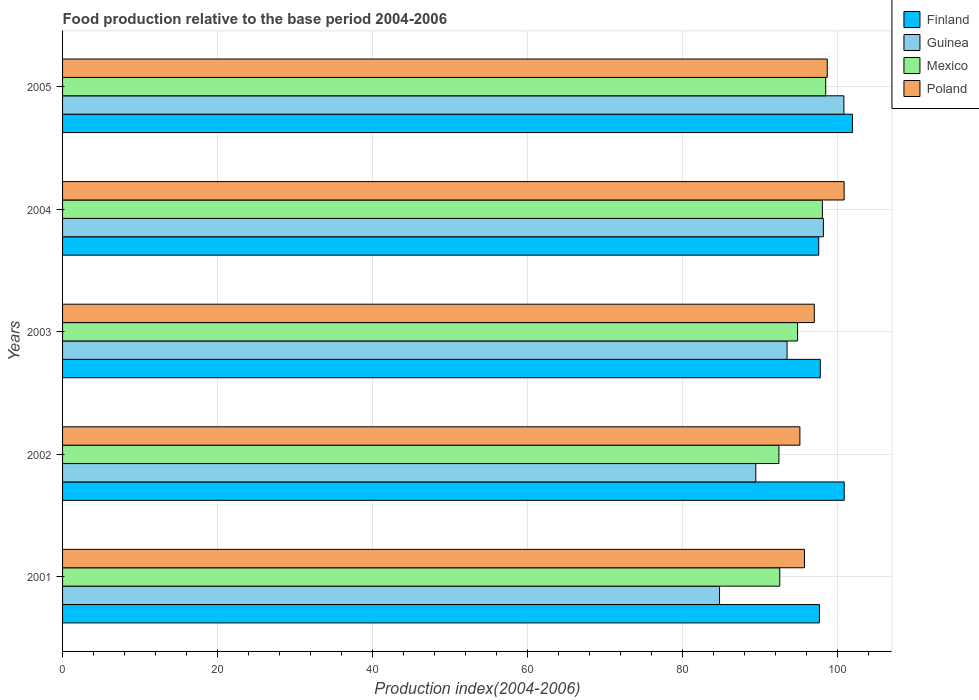Are the number of bars per tick equal to the number of legend labels?
Provide a succinct answer. Yes. Are the number of bars on each tick of the Y-axis equal?
Offer a very short reply. Yes. How many bars are there on the 3rd tick from the top?
Offer a terse response. 4. What is the label of the 3rd group of bars from the top?
Your response must be concise. 2003. What is the food production index in Poland in 2004?
Give a very brief answer. 100.87. Across all years, what is the maximum food production index in Poland?
Make the answer very short. 100.87. Across all years, what is the minimum food production index in Mexico?
Your answer should be very brief. 92.45. In which year was the food production index in Poland maximum?
Provide a short and direct response. 2004. In which year was the food production index in Poland minimum?
Provide a succinct answer. 2002. What is the total food production index in Poland in the graph?
Make the answer very short. 487.49. What is the difference between the food production index in Mexico in 2001 and that in 2002?
Offer a terse response. 0.11. What is the difference between the food production index in Poland in 2004 and the food production index in Mexico in 2003?
Offer a very short reply. 6.01. What is the average food production index in Mexico per year?
Provide a short and direct response. 95.28. In the year 2005, what is the difference between the food production index in Mexico and food production index in Finland?
Give a very brief answer. -3.45. In how many years, is the food production index in Guinea greater than 40 ?
Your answer should be very brief. 5. What is the ratio of the food production index in Finland in 2002 to that in 2004?
Your response must be concise. 1.03. Is the food production index in Finland in 2002 less than that in 2004?
Your answer should be very brief. No. What is the difference between the highest and the second highest food production index in Poland?
Offer a very short reply. 2.18. What is the difference between the highest and the lowest food production index in Poland?
Your response must be concise. 5.71. In how many years, is the food production index in Poland greater than the average food production index in Poland taken over all years?
Give a very brief answer. 2. Is it the case that in every year, the sum of the food production index in Mexico and food production index in Poland is greater than the sum of food production index in Guinea and food production index in Finland?
Your answer should be compact. No. What does the 3rd bar from the top in 2003 represents?
Offer a very short reply. Guinea. What does the 2nd bar from the bottom in 2005 represents?
Your response must be concise. Guinea. How many bars are there?
Ensure brevity in your answer.  20. What is the difference between two consecutive major ticks on the X-axis?
Keep it short and to the point. 20. Are the values on the major ticks of X-axis written in scientific E-notation?
Your answer should be compact. No. Does the graph contain any zero values?
Your answer should be compact. No. Where does the legend appear in the graph?
Give a very brief answer. Top right. How many legend labels are there?
Provide a succinct answer. 4. How are the legend labels stacked?
Your response must be concise. Vertical. What is the title of the graph?
Your response must be concise. Food production relative to the base period 2004-2006. What is the label or title of the X-axis?
Provide a succinct answer. Production index(2004-2006). What is the Production index(2004-2006) of Finland in 2001?
Ensure brevity in your answer.  97.68. What is the Production index(2004-2006) in Guinea in 2001?
Provide a succinct answer. 84.79. What is the Production index(2004-2006) in Mexico in 2001?
Your answer should be very brief. 92.56. What is the Production index(2004-2006) of Poland in 2001?
Give a very brief answer. 95.75. What is the Production index(2004-2006) in Finland in 2002?
Your answer should be very brief. 100.88. What is the Production index(2004-2006) of Guinea in 2002?
Your answer should be compact. 89.47. What is the Production index(2004-2006) in Mexico in 2002?
Provide a succinct answer. 92.45. What is the Production index(2004-2006) in Poland in 2002?
Give a very brief answer. 95.16. What is the Production index(2004-2006) of Finland in 2003?
Your answer should be compact. 97.79. What is the Production index(2004-2006) of Guinea in 2003?
Provide a succinct answer. 93.5. What is the Production index(2004-2006) in Mexico in 2003?
Your answer should be very brief. 94.86. What is the Production index(2004-2006) of Poland in 2003?
Your answer should be compact. 97.02. What is the Production index(2004-2006) in Finland in 2004?
Your response must be concise. 97.59. What is the Production index(2004-2006) in Guinea in 2004?
Make the answer very short. 98.19. What is the Production index(2004-2006) of Mexico in 2004?
Your response must be concise. 98.06. What is the Production index(2004-2006) in Poland in 2004?
Provide a short and direct response. 100.87. What is the Production index(2004-2006) in Finland in 2005?
Provide a short and direct response. 101.94. What is the Production index(2004-2006) of Guinea in 2005?
Give a very brief answer. 100.84. What is the Production index(2004-2006) of Mexico in 2005?
Ensure brevity in your answer.  98.49. What is the Production index(2004-2006) in Poland in 2005?
Ensure brevity in your answer.  98.69. Across all years, what is the maximum Production index(2004-2006) of Finland?
Keep it short and to the point. 101.94. Across all years, what is the maximum Production index(2004-2006) in Guinea?
Your answer should be compact. 100.84. Across all years, what is the maximum Production index(2004-2006) of Mexico?
Keep it short and to the point. 98.49. Across all years, what is the maximum Production index(2004-2006) of Poland?
Offer a very short reply. 100.87. Across all years, what is the minimum Production index(2004-2006) of Finland?
Provide a short and direct response. 97.59. Across all years, what is the minimum Production index(2004-2006) of Guinea?
Offer a terse response. 84.79. Across all years, what is the minimum Production index(2004-2006) in Mexico?
Ensure brevity in your answer.  92.45. Across all years, what is the minimum Production index(2004-2006) in Poland?
Offer a terse response. 95.16. What is the total Production index(2004-2006) of Finland in the graph?
Your response must be concise. 495.88. What is the total Production index(2004-2006) in Guinea in the graph?
Provide a short and direct response. 466.79. What is the total Production index(2004-2006) of Mexico in the graph?
Keep it short and to the point. 476.42. What is the total Production index(2004-2006) in Poland in the graph?
Provide a short and direct response. 487.49. What is the difference between the Production index(2004-2006) of Guinea in 2001 and that in 2002?
Provide a succinct answer. -4.68. What is the difference between the Production index(2004-2006) of Mexico in 2001 and that in 2002?
Give a very brief answer. 0.11. What is the difference between the Production index(2004-2006) of Poland in 2001 and that in 2002?
Make the answer very short. 0.59. What is the difference between the Production index(2004-2006) in Finland in 2001 and that in 2003?
Offer a terse response. -0.11. What is the difference between the Production index(2004-2006) of Guinea in 2001 and that in 2003?
Your response must be concise. -8.71. What is the difference between the Production index(2004-2006) in Poland in 2001 and that in 2003?
Offer a very short reply. -1.27. What is the difference between the Production index(2004-2006) in Finland in 2001 and that in 2004?
Ensure brevity in your answer.  0.09. What is the difference between the Production index(2004-2006) of Guinea in 2001 and that in 2004?
Your answer should be compact. -13.4. What is the difference between the Production index(2004-2006) of Poland in 2001 and that in 2004?
Give a very brief answer. -5.12. What is the difference between the Production index(2004-2006) of Finland in 2001 and that in 2005?
Keep it short and to the point. -4.26. What is the difference between the Production index(2004-2006) in Guinea in 2001 and that in 2005?
Give a very brief answer. -16.05. What is the difference between the Production index(2004-2006) of Mexico in 2001 and that in 2005?
Make the answer very short. -5.93. What is the difference between the Production index(2004-2006) in Poland in 2001 and that in 2005?
Offer a very short reply. -2.94. What is the difference between the Production index(2004-2006) of Finland in 2002 and that in 2003?
Your answer should be very brief. 3.09. What is the difference between the Production index(2004-2006) in Guinea in 2002 and that in 2003?
Ensure brevity in your answer.  -4.03. What is the difference between the Production index(2004-2006) of Mexico in 2002 and that in 2003?
Offer a very short reply. -2.41. What is the difference between the Production index(2004-2006) in Poland in 2002 and that in 2003?
Your answer should be very brief. -1.86. What is the difference between the Production index(2004-2006) of Finland in 2002 and that in 2004?
Ensure brevity in your answer.  3.29. What is the difference between the Production index(2004-2006) in Guinea in 2002 and that in 2004?
Make the answer very short. -8.72. What is the difference between the Production index(2004-2006) in Mexico in 2002 and that in 2004?
Ensure brevity in your answer.  -5.61. What is the difference between the Production index(2004-2006) of Poland in 2002 and that in 2004?
Your answer should be compact. -5.71. What is the difference between the Production index(2004-2006) in Finland in 2002 and that in 2005?
Give a very brief answer. -1.06. What is the difference between the Production index(2004-2006) in Guinea in 2002 and that in 2005?
Your answer should be very brief. -11.37. What is the difference between the Production index(2004-2006) of Mexico in 2002 and that in 2005?
Provide a succinct answer. -6.04. What is the difference between the Production index(2004-2006) in Poland in 2002 and that in 2005?
Make the answer very short. -3.53. What is the difference between the Production index(2004-2006) in Guinea in 2003 and that in 2004?
Make the answer very short. -4.69. What is the difference between the Production index(2004-2006) of Poland in 2003 and that in 2004?
Keep it short and to the point. -3.85. What is the difference between the Production index(2004-2006) in Finland in 2003 and that in 2005?
Your answer should be very brief. -4.15. What is the difference between the Production index(2004-2006) in Guinea in 2003 and that in 2005?
Ensure brevity in your answer.  -7.34. What is the difference between the Production index(2004-2006) in Mexico in 2003 and that in 2005?
Offer a terse response. -3.63. What is the difference between the Production index(2004-2006) of Poland in 2003 and that in 2005?
Your answer should be compact. -1.67. What is the difference between the Production index(2004-2006) in Finland in 2004 and that in 2005?
Keep it short and to the point. -4.35. What is the difference between the Production index(2004-2006) of Guinea in 2004 and that in 2005?
Your answer should be compact. -2.65. What is the difference between the Production index(2004-2006) of Mexico in 2004 and that in 2005?
Provide a succinct answer. -0.43. What is the difference between the Production index(2004-2006) of Poland in 2004 and that in 2005?
Your answer should be very brief. 2.18. What is the difference between the Production index(2004-2006) in Finland in 2001 and the Production index(2004-2006) in Guinea in 2002?
Give a very brief answer. 8.21. What is the difference between the Production index(2004-2006) of Finland in 2001 and the Production index(2004-2006) of Mexico in 2002?
Your answer should be very brief. 5.23. What is the difference between the Production index(2004-2006) in Finland in 2001 and the Production index(2004-2006) in Poland in 2002?
Keep it short and to the point. 2.52. What is the difference between the Production index(2004-2006) of Guinea in 2001 and the Production index(2004-2006) of Mexico in 2002?
Your response must be concise. -7.66. What is the difference between the Production index(2004-2006) in Guinea in 2001 and the Production index(2004-2006) in Poland in 2002?
Offer a terse response. -10.37. What is the difference between the Production index(2004-2006) in Finland in 2001 and the Production index(2004-2006) in Guinea in 2003?
Keep it short and to the point. 4.18. What is the difference between the Production index(2004-2006) in Finland in 2001 and the Production index(2004-2006) in Mexico in 2003?
Offer a very short reply. 2.82. What is the difference between the Production index(2004-2006) in Finland in 2001 and the Production index(2004-2006) in Poland in 2003?
Ensure brevity in your answer.  0.66. What is the difference between the Production index(2004-2006) in Guinea in 2001 and the Production index(2004-2006) in Mexico in 2003?
Offer a terse response. -10.07. What is the difference between the Production index(2004-2006) of Guinea in 2001 and the Production index(2004-2006) of Poland in 2003?
Give a very brief answer. -12.23. What is the difference between the Production index(2004-2006) of Mexico in 2001 and the Production index(2004-2006) of Poland in 2003?
Your response must be concise. -4.46. What is the difference between the Production index(2004-2006) in Finland in 2001 and the Production index(2004-2006) in Guinea in 2004?
Offer a very short reply. -0.51. What is the difference between the Production index(2004-2006) of Finland in 2001 and the Production index(2004-2006) of Mexico in 2004?
Provide a succinct answer. -0.38. What is the difference between the Production index(2004-2006) of Finland in 2001 and the Production index(2004-2006) of Poland in 2004?
Give a very brief answer. -3.19. What is the difference between the Production index(2004-2006) of Guinea in 2001 and the Production index(2004-2006) of Mexico in 2004?
Your response must be concise. -13.27. What is the difference between the Production index(2004-2006) in Guinea in 2001 and the Production index(2004-2006) in Poland in 2004?
Your answer should be compact. -16.08. What is the difference between the Production index(2004-2006) in Mexico in 2001 and the Production index(2004-2006) in Poland in 2004?
Give a very brief answer. -8.31. What is the difference between the Production index(2004-2006) in Finland in 2001 and the Production index(2004-2006) in Guinea in 2005?
Ensure brevity in your answer.  -3.16. What is the difference between the Production index(2004-2006) of Finland in 2001 and the Production index(2004-2006) of Mexico in 2005?
Provide a short and direct response. -0.81. What is the difference between the Production index(2004-2006) in Finland in 2001 and the Production index(2004-2006) in Poland in 2005?
Provide a short and direct response. -1.01. What is the difference between the Production index(2004-2006) in Guinea in 2001 and the Production index(2004-2006) in Mexico in 2005?
Provide a succinct answer. -13.7. What is the difference between the Production index(2004-2006) of Mexico in 2001 and the Production index(2004-2006) of Poland in 2005?
Keep it short and to the point. -6.13. What is the difference between the Production index(2004-2006) of Finland in 2002 and the Production index(2004-2006) of Guinea in 2003?
Your answer should be very brief. 7.38. What is the difference between the Production index(2004-2006) of Finland in 2002 and the Production index(2004-2006) of Mexico in 2003?
Keep it short and to the point. 6.02. What is the difference between the Production index(2004-2006) of Finland in 2002 and the Production index(2004-2006) of Poland in 2003?
Your response must be concise. 3.86. What is the difference between the Production index(2004-2006) of Guinea in 2002 and the Production index(2004-2006) of Mexico in 2003?
Your answer should be compact. -5.39. What is the difference between the Production index(2004-2006) of Guinea in 2002 and the Production index(2004-2006) of Poland in 2003?
Your response must be concise. -7.55. What is the difference between the Production index(2004-2006) in Mexico in 2002 and the Production index(2004-2006) in Poland in 2003?
Ensure brevity in your answer.  -4.57. What is the difference between the Production index(2004-2006) of Finland in 2002 and the Production index(2004-2006) of Guinea in 2004?
Your response must be concise. 2.69. What is the difference between the Production index(2004-2006) of Finland in 2002 and the Production index(2004-2006) of Mexico in 2004?
Your response must be concise. 2.82. What is the difference between the Production index(2004-2006) of Guinea in 2002 and the Production index(2004-2006) of Mexico in 2004?
Offer a very short reply. -8.59. What is the difference between the Production index(2004-2006) of Guinea in 2002 and the Production index(2004-2006) of Poland in 2004?
Offer a terse response. -11.4. What is the difference between the Production index(2004-2006) in Mexico in 2002 and the Production index(2004-2006) in Poland in 2004?
Your answer should be compact. -8.42. What is the difference between the Production index(2004-2006) in Finland in 2002 and the Production index(2004-2006) in Mexico in 2005?
Keep it short and to the point. 2.39. What is the difference between the Production index(2004-2006) in Finland in 2002 and the Production index(2004-2006) in Poland in 2005?
Offer a very short reply. 2.19. What is the difference between the Production index(2004-2006) in Guinea in 2002 and the Production index(2004-2006) in Mexico in 2005?
Give a very brief answer. -9.02. What is the difference between the Production index(2004-2006) in Guinea in 2002 and the Production index(2004-2006) in Poland in 2005?
Keep it short and to the point. -9.22. What is the difference between the Production index(2004-2006) in Mexico in 2002 and the Production index(2004-2006) in Poland in 2005?
Ensure brevity in your answer.  -6.24. What is the difference between the Production index(2004-2006) of Finland in 2003 and the Production index(2004-2006) of Guinea in 2004?
Offer a terse response. -0.4. What is the difference between the Production index(2004-2006) in Finland in 2003 and the Production index(2004-2006) in Mexico in 2004?
Make the answer very short. -0.27. What is the difference between the Production index(2004-2006) in Finland in 2003 and the Production index(2004-2006) in Poland in 2004?
Make the answer very short. -3.08. What is the difference between the Production index(2004-2006) in Guinea in 2003 and the Production index(2004-2006) in Mexico in 2004?
Your answer should be very brief. -4.56. What is the difference between the Production index(2004-2006) in Guinea in 2003 and the Production index(2004-2006) in Poland in 2004?
Offer a terse response. -7.37. What is the difference between the Production index(2004-2006) of Mexico in 2003 and the Production index(2004-2006) of Poland in 2004?
Offer a terse response. -6.01. What is the difference between the Production index(2004-2006) of Finland in 2003 and the Production index(2004-2006) of Guinea in 2005?
Make the answer very short. -3.05. What is the difference between the Production index(2004-2006) in Finland in 2003 and the Production index(2004-2006) in Poland in 2005?
Keep it short and to the point. -0.9. What is the difference between the Production index(2004-2006) of Guinea in 2003 and the Production index(2004-2006) of Mexico in 2005?
Keep it short and to the point. -4.99. What is the difference between the Production index(2004-2006) in Guinea in 2003 and the Production index(2004-2006) in Poland in 2005?
Provide a short and direct response. -5.19. What is the difference between the Production index(2004-2006) in Mexico in 2003 and the Production index(2004-2006) in Poland in 2005?
Give a very brief answer. -3.83. What is the difference between the Production index(2004-2006) of Finland in 2004 and the Production index(2004-2006) of Guinea in 2005?
Make the answer very short. -3.25. What is the difference between the Production index(2004-2006) of Finland in 2004 and the Production index(2004-2006) of Mexico in 2005?
Make the answer very short. -0.9. What is the difference between the Production index(2004-2006) in Guinea in 2004 and the Production index(2004-2006) in Mexico in 2005?
Your answer should be compact. -0.3. What is the difference between the Production index(2004-2006) of Mexico in 2004 and the Production index(2004-2006) of Poland in 2005?
Offer a very short reply. -0.63. What is the average Production index(2004-2006) in Finland per year?
Give a very brief answer. 99.18. What is the average Production index(2004-2006) of Guinea per year?
Make the answer very short. 93.36. What is the average Production index(2004-2006) in Mexico per year?
Your answer should be compact. 95.28. What is the average Production index(2004-2006) of Poland per year?
Provide a short and direct response. 97.5. In the year 2001, what is the difference between the Production index(2004-2006) in Finland and Production index(2004-2006) in Guinea?
Keep it short and to the point. 12.89. In the year 2001, what is the difference between the Production index(2004-2006) in Finland and Production index(2004-2006) in Mexico?
Your answer should be compact. 5.12. In the year 2001, what is the difference between the Production index(2004-2006) of Finland and Production index(2004-2006) of Poland?
Offer a terse response. 1.93. In the year 2001, what is the difference between the Production index(2004-2006) in Guinea and Production index(2004-2006) in Mexico?
Offer a terse response. -7.77. In the year 2001, what is the difference between the Production index(2004-2006) in Guinea and Production index(2004-2006) in Poland?
Provide a succinct answer. -10.96. In the year 2001, what is the difference between the Production index(2004-2006) in Mexico and Production index(2004-2006) in Poland?
Offer a very short reply. -3.19. In the year 2002, what is the difference between the Production index(2004-2006) in Finland and Production index(2004-2006) in Guinea?
Your answer should be very brief. 11.41. In the year 2002, what is the difference between the Production index(2004-2006) in Finland and Production index(2004-2006) in Mexico?
Ensure brevity in your answer.  8.43. In the year 2002, what is the difference between the Production index(2004-2006) in Finland and Production index(2004-2006) in Poland?
Provide a short and direct response. 5.72. In the year 2002, what is the difference between the Production index(2004-2006) of Guinea and Production index(2004-2006) of Mexico?
Offer a very short reply. -2.98. In the year 2002, what is the difference between the Production index(2004-2006) in Guinea and Production index(2004-2006) in Poland?
Ensure brevity in your answer.  -5.69. In the year 2002, what is the difference between the Production index(2004-2006) in Mexico and Production index(2004-2006) in Poland?
Your answer should be compact. -2.71. In the year 2003, what is the difference between the Production index(2004-2006) in Finland and Production index(2004-2006) in Guinea?
Offer a very short reply. 4.29. In the year 2003, what is the difference between the Production index(2004-2006) in Finland and Production index(2004-2006) in Mexico?
Ensure brevity in your answer.  2.93. In the year 2003, what is the difference between the Production index(2004-2006) in Finland and Production index(2004-2006) in Poland?
Your answer should be very brief. 0.77. In the year 2003, what is the difference between the Production index(2004-2006) of Guinea and Production index(2004-2006) of Mexico?
Ensure brevity in your answer.  -1.36. In the year 2003, what is the difference between the Production index(2004-2006) of Guinea and Production index(2004-2006) of Poland?
Your response must be concise. -3.52. In the year 2003, what is the difference between the Production index(2004-2006) in Mexico and Production index(2004-2006) in Poland?
Give a very brief answer. -2.16. In the year 2004, what is the difference between the Production index(2004-2006) in Finland and Production index(2004-2006) in Guinea?
Offer a terse response. -0.6. In the year 2004, what is the difference between the Production index(2004-2006) in Finland and Production index(2004-2006) in Mexico?
Offer a terse response. -0.47. In the year 2004, what is the difference between the Production index(2004-2006) in Finland and Production index(2004-2006) in Poland?
Provide a short and direct response. -3.28. In the year 2004, what is the difference between the Production index(2004-2006) of Guinea and Production index(2004-2006) of Mexico?
Provide a succinct answer. 0.13. In the year 2004, what is the difference between the Production index(2004-2006) in Guinea and Production index(2004-2006) in Poland?
Give a very brief answer. -2.68. In the year 2004, what is the difference between the Production index(2004-2006) in Mexico and Production index(2004-2006) in Poland?
Keep it short and to the point. -2.81. In the year 2005, what is the difference between the Production index(2004-2006) in Finland and Production index(2004-2006) in Mexico?
Ensure brevity in your answer.  3.45. In the year 2005, what is the difference between the Production index(2004-2006) in Finland and Production index(2004-2006) in Poland?
Provide a short and direct response. 3.25. In the year 2005, what is the difference between the Production index(2004-2006) of Guinea and Production index(2004-2006) of Mexico?
Offer a terse response. 2.35. In the year 2005, what is the difference between the Production index(2004-2006) of Guinea and Production index(2004-2006) of Poland?
Give a very brief answer. 2.15. What is the ratio of the Production index(2004-2006) of Finland in 2001 to that in 2002?
Make the answer very short. 0.97. What is the ratio of the Production index(2004-2006) in Guinea in 2001 to that in 2002?
Your answer should be compact. 0.95. What is the ratio of the Production index(2004-2006) in Mexico in 2001 to that in 2002?
Provide a short and direct response. 1. What is the ratio of the Production index(2004-2006) in Guinea in 2001 to that in 2003?
Offer a terse response. 0.91. What is the ratio of the Production index(2004-2006) in Mexico in 2001 to that in 2003?
Offer a very short reply. 0.98. What is the ratio of the Production index(2004-2006) in Poland in 2001 to that in 2003?
Provide a succinct answer. 0.99. What is the ratio of the Production index(2004-2006) in Finland in 2001 to that in 2004?
Your answer should be compact. 1. What is the ratio of the Production index(2004-2006) in Guinea in 2001 to that in 2004?
Your answer should be very brief. 0.86. What is the ratio of the Production index(2004-2006) in Mexico in 2001 to that in 2004?
Offer a terse response. 0.94. What is the ratio of the Production index(2004-2006) in Poland in 2001 to that in 2004?
Your answer should be very brief. 0.95. What is the ratio of the Production index(2004-2006) in Finland in 2001 to that in 2005?
Your response must be concise. 0.96. What is the ratio of the Production index(2004-2006) in Guinea in 2001 to that in 2005?
Your answer should be very brief. 0.84. What is the ratio of the Production index(2004-2006) of Mexico in 2001 to that in 2005?
Ensure brevity in your answer.  0.94. What is the ratio of the Production index(2004-2006) in Poland in 2001 to that in 2005?
Your answer should be very brief. 0.97. What is the ratio of the Production index(2004-2006) in Finland in 2002 to that in 2003?
Keep it short and to the point. 1.03. What is the ratio of the Production index(2004-2006) of Guinea in 2002 to that in 2003?
Ensure brevity in your answer.  0.96. What is the ratio of the Production index(2004-2006) in Mexico in 2002 to that in 2003?
Offer a terse response. 0.97. What is the ratio of the Production index(2004-2006) of Poland in 2002 to that in 2003?
Your response must be concise. 0.98. What is the ratio of the Production index(2004-2006) in Finland in 2002 to that in 2004?
Your answer should be compact. 1.03. What is the ratio of the Production index(2004-2006) of Guinea in 2002 to that in 2004?
Your response must be concise. 0.91. What is the ratio of the Production index(2004-2006) in Mexico in 2002 to that in 2004?
Provide a succinct answer. 0.94. What is the ratio of the Production index(2004-2006) in Poland in 2002 to that in 2004?
Keep it short and to the point. 0.94. What is the ratio of the Production index(2004-2006) of Finland in 2002 to that in 2005?
Your answer should be compact. 0.99. What is the ratio of the Production index(2004-2006) of Guinea in 2002 to that in 2005?
Offer a very short reply. 0.89. What is the ratio of the Production index(2004-2006) of Mexico in 2002 to that in 2005?
Your answer should be very brief. 0.94. What is the ratio of the Production index(2004-2006) of Poland in 2002 to that in 2005?
Your answer should be compact. 0.96. What is the ratio of the Production index(2004-2006) of Guinea in 2003 to that in 2004?
Give a very brief answer. 0.95. What is the ratio of the Production index(2004-2006) in Mexico in 2003 to that in 2004?
Provide a short and direct response. 0.97. What is the ratio of the Production index(2004-2006) of Poland in 2003 to that in 2004?
Provide a short and direct response. 0.96. What is the ratio of the Production index(2004-2006) of Finland in 2003 to that in 2005?
Your response must be concise. 0.96. What is the ratio of the Production index(2004-2006) of Guinea in 2003 to that in 2005?
Your answer should be very brief. 0.93. What is the ratio of the Production index(2004-2006) in Mexico in 2003 to that in 2005?
Provide a succinct answer. 0.96. What is the ratio of the Production index(2004-2006) of Poland in 2003 to that in 2005?
Provide a succinct answer. 0.98. What is the ratio of the Production index(2004-2006) of Finland in 2004 to that in 2005?
Give a very brief answer. 0.96. What is the ratio of the Production index(2004-2006) of Guinea in 2004 to that in 2005?
Offer a terse response. 0.97. What is the ratio of the Production index(2004-2006) of Mexico in 2004 to that in 2005?
Your answer should be very brief. 1. What is the ratio of the Production index(2004-2006) in Poland in 2004 to that in 2005?
Give a very brief answer. 1.02. What is the difference between the highest and the second highest Production index(2004-2006) of Finland?
Your answer should be very brief. 1.06. What is the difference between the highest and the second highest Production index(2004-2006) of Guinea?
Keep it short and to the point. 2.65. What is the difference between the highest and the second highest Production index(2004-2006) of Mexico?
Provide a succinct answer. 0.43. What is the difference between the highest and the second highest Production index(2004-2006) in Poland?
Offer a very short reply. 2.18. What is the difference between the highest and the lowest Production index(2004-2006) in Finland?
Give a very brief answer. 4.35. What is the difference between the highest and the lowest Production index(2004-2006) in Guinea?
Provide a short and direct response. 16.05. What is the difference between the highest and the lowest Production index(2004-2006) in Mexico?
Your answer should be compact. 6.04. What is the difference between the highest and the lowest Production index(2004-2006) in Poland?
Your answer should be compact. 5.71. 